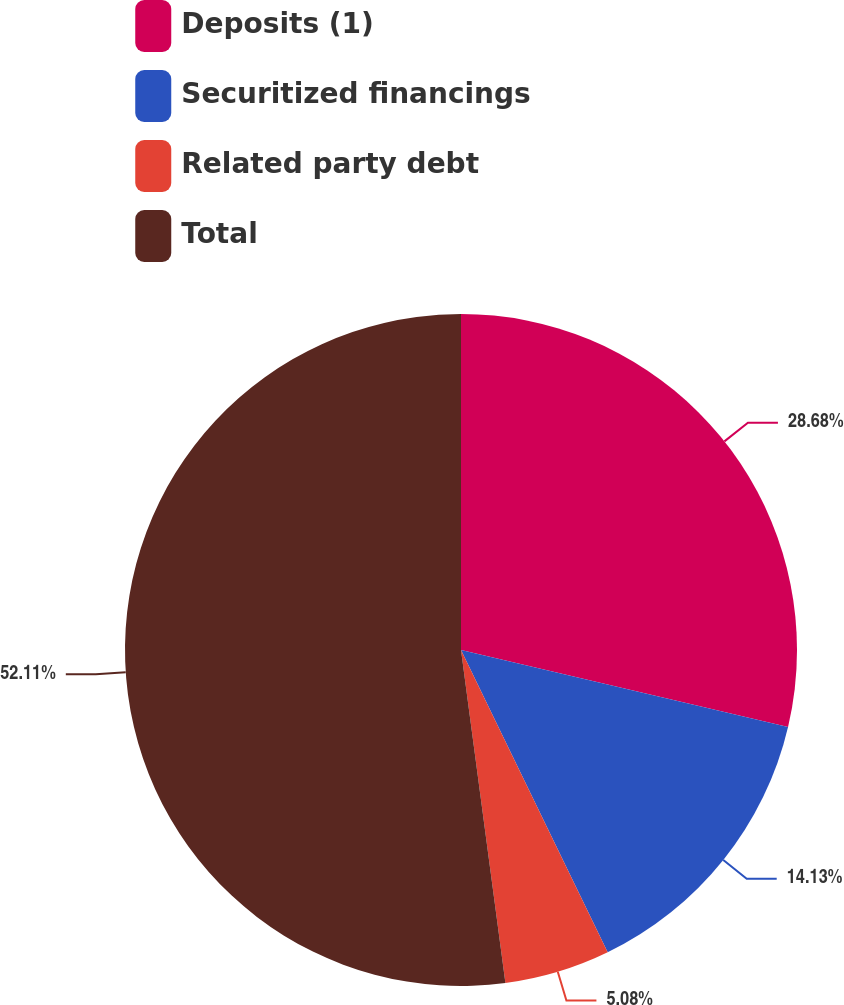Convert chart. <chart><loc_0><loc_0><loc_500><loc_500><pie_chart><fcel>Deposits (1)<fcel>Securitized financings<fcel>Related party debt<fcel>Total<nl><fcel>28.68%<fcel>14.13%<fcel>5.08%<fcel>52.11%<nl></chart> 